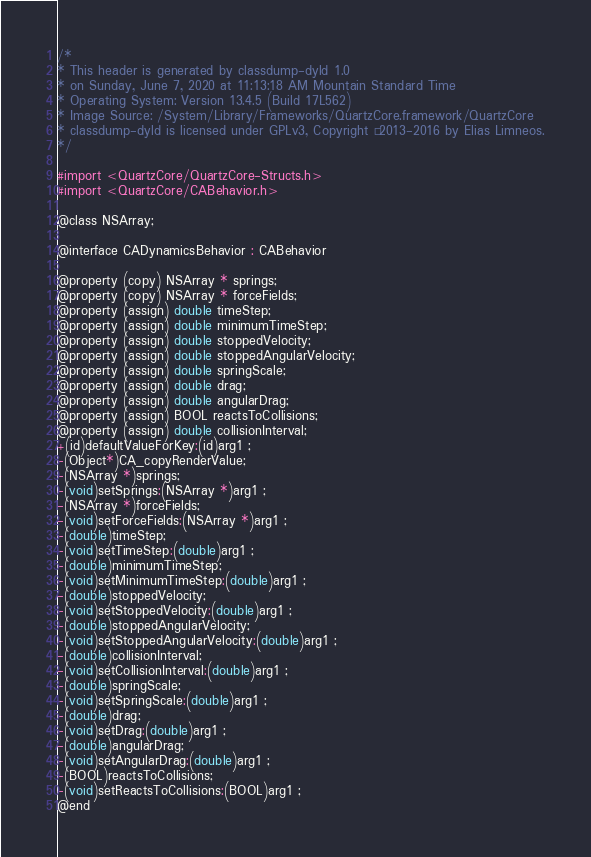Convert code to text. <code><loc_0><loc_0><loc_500><loc_500><_C_>/*
* This header is generated by classdump-dyld 1.0
* on Sunday, June 7, 2020 at 11:13:18 AM Mountain Standard Time
* Operating System: Version 13.4.5 (Build 17L562)
* Image Source: /System/Library/Frameworks/QuartzCore.framework/QuartzCore
* classdump-dyld is licensed under GPLv3, Copyright © 2013-2016 by Elias Limneos.
*/

#import <QuartzCore/QuartzCore-Structs.h>
#import <QuartzCore/CABehavior.h>

@class NSArray;

@interface CADynamicsBehavior : CABehavior

@property (copy) NSArray * springs; 
@property (copy) NSArray * forceFields; 
@property (assign) double timeStep; 
@property (assign) double minimumTimeStep; 
@property (assign) double stoppedVelocity; 
@property (assign) double stoppedAngularVelocity; 
@property (assign) double springScale; 
@property (assign) double drag; 
@property (assign) double angularDrag; 
@property (assign) BOOL reactsToCollisions; 
@property (assign) double collisionInterval; 
+(id)defaultValueForKey:(id)arg1 ;
-(Object*)CA_copyRenderValue;
-(NSArray *)springs;
-(void)setSprings:(NSArray *)arg1 ;
-(NSArray *)forceFields;
-(void)setForceFields:(NSArray *)arg1 ;
-(double)timeStep;
-(void)setTimeStep:(double)arg1 ;
-(double)minimumTimeStep;
-(void)setMinimumTimeStep:(double)arg1 ;
-(double)stoppedVelocity;
-(void)setStoppedVelocity:(double)arg1 ;
-(double)stoppedAngularVelocity;
-(void)setStoppedAngularVelocity:(double)arg1 ;
-(double)collisionInterval;
-(void)setCollisionInterval:(double)arg1 ;
-(double)springScale;
-(void)setSpringScale:(double)arg1 ;
-(double)drag;
-(void)setDrag:(double)arg1 ;
-(double)angularDrag;
-(void)setAngularDrag:(double)arg1 ;
-(BOOL)reactsToCollisions;
-(void)setReactsToCollisions:(BOOL)arg1 ;
@end

</code> 